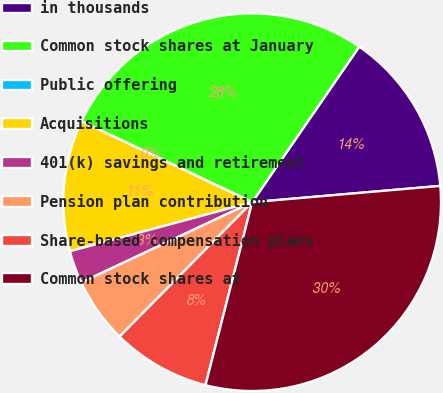Convert chart. <chart><loc_0><loc_0><loc_500><loc_500><pie_chart><fcel>in thousands<fcel>Common stock shares at January<fcel>Public offering<fcel>Acquisitions<fcel>401(k) savings and retirement<fcel>Pension plan contribution<fcel>Share-based compensation plans<fcel>Common stock shares at<nl><fcel>14.03%<fcel>27.55%<fcel>0.0%<fcel>11.23%<fcel>2.81%<fcel>5.61%<fcel>8.42%<fcel>30.35%<nl></chart> 